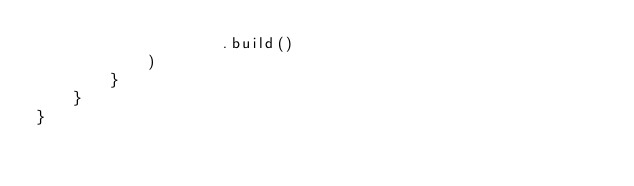<code> <loc_0><loc_0><loc_500><loc_500><_Kotlin_>                    .build()
            )
        }
    }
}
</code> 